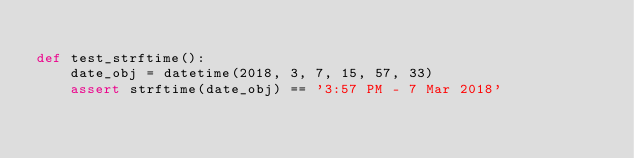Convert code to text. <code><loc_0><loc_0><loc_500><loc_500><_Python_>
def test_strftime():
    date_obj = datetime(2018, 3, 7, 15, 57, 33)
    assert strftime(date_obj) == '3:57 PM - 7 Mar 2018'
</code> 